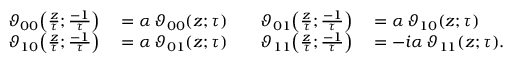Convert formula to latex. <formula><loc_0><loc_0><loc_500><loc_500>\begin{array} { r l r l } { \vartheta _ { 0 0 } \, \left ( { \frac { z } { \tau } } ; { \frac { - 1 } { \tau } } \right ) } & = \alpha \, \vartheta _ { 0 0 } ( z ; \tau ) \quad } & { \vartheta _ { 0 1 } \, \left ( { \frac { z } { \tau } } ; { \frac { - 1 } { \tau } } \right ) } & = \alpha \, \vartheta _ { 1 0 } ( z ; \tau ) } \\ { \vartheta _ { 1 0 } \, \left ( { \frac { z } { \tau } } ; { \frac { - 1 } { \tau } } \right ) } & = \alpha \, \vartheta _ { 0 1 } ( z ; \tau ) \quad } & { \vartheta _ { 1 1 } \, \left ( { \frac { z } { \tau } } ; { \frac { - 1 } { \tau } } \right ) } & = - i \alpha \, \vartheta _ { 1 1 } ( z ; \tau ) . } \end{array}</formula> 